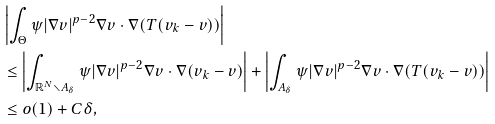Convert formula to latex. <formula><loc_0><loc_0><loc_500><loc_500>& \left | \int _ { \Theta } \psi | \nabla v | ^ { p - 2 } \nabla v \cdot \nabla ( T ( v _ { k } - v ) ) \right | \\ & \leq \left | \int _ { \mathbb { R } ^ { N } \smallsetminus A _ { \delta } } \psi | \nabla v | ^ { p - 2 } \nabla v \cdot \nabla ( v _ { k } - v ) \right | + \left | \int _ { A _ { \delta } } \psi | \nabla v | ^ { p - 2 } \nabla v \cdot \nabla ( T ( v _ { k } - v ) ) \right | \\ & \leq o ( 1 ) + C \delta ,</formula> 